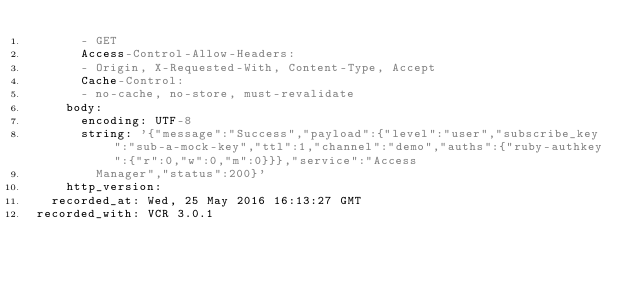<code> <loc_0><loc_0><loc_500><loc_500><_YAML_>      - GET
      Access-Control-Allow-Headers:
      - Origin, X-Requested-With, Content-Type, Accept
      Cache-Control:
      - no-cache, no-store, must-revalidate
    body:
      encoding: UTF-8
      string: '{"message":"Success","payload":{"level":"user","subscribe_key":"sub-a-mock-key","ttl":1,"channel":"demo","auths":{"ruby-authkey":{"r":0,"w":0,"m":0}}},"service":"Access
        Manager","status":200}'
    http_version: 
  recorded_at: Wed, 25 May 2016 16:13:27 GMT
recorded_with: VCR 3.0.1
</code> 